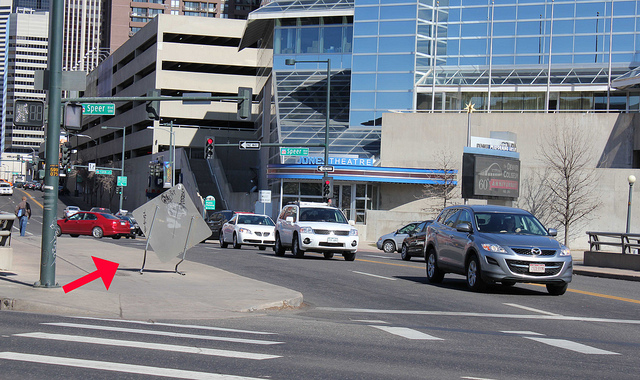Identify and read out the text in this image. THEATRE Speed 88 